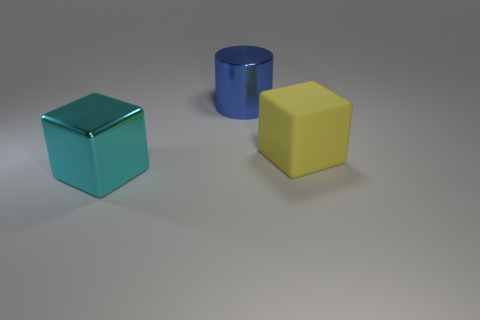What number of other things are there of the same size as the rubber cube? 2 